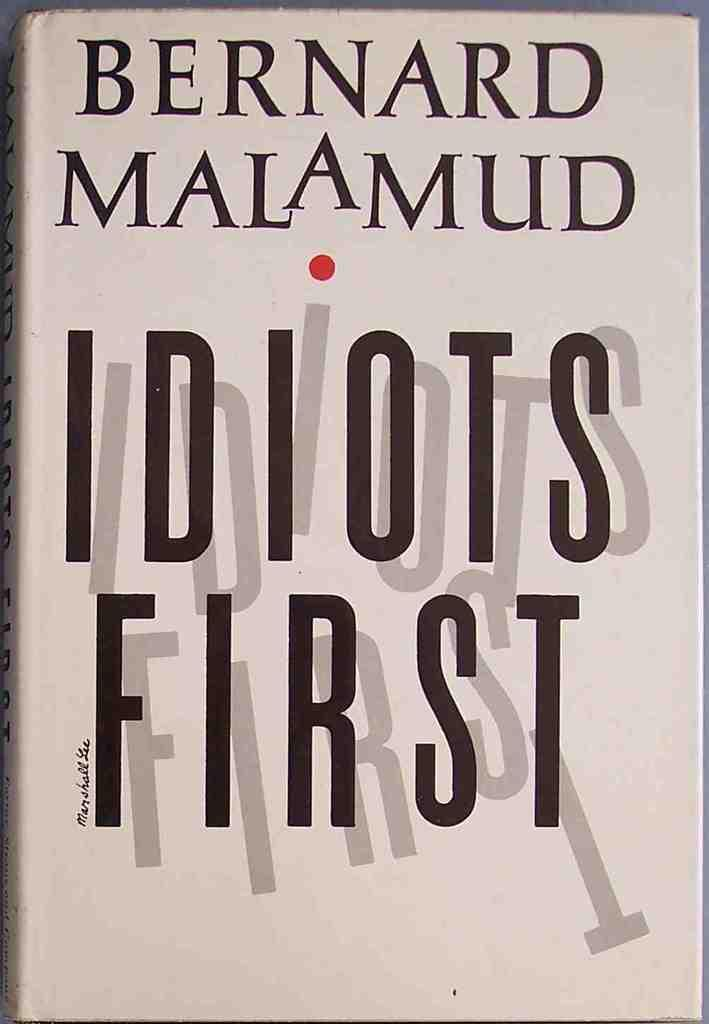Provide a one-sentence caption for the provided image. Bernard Malamud wrote this book called Idiots First. 